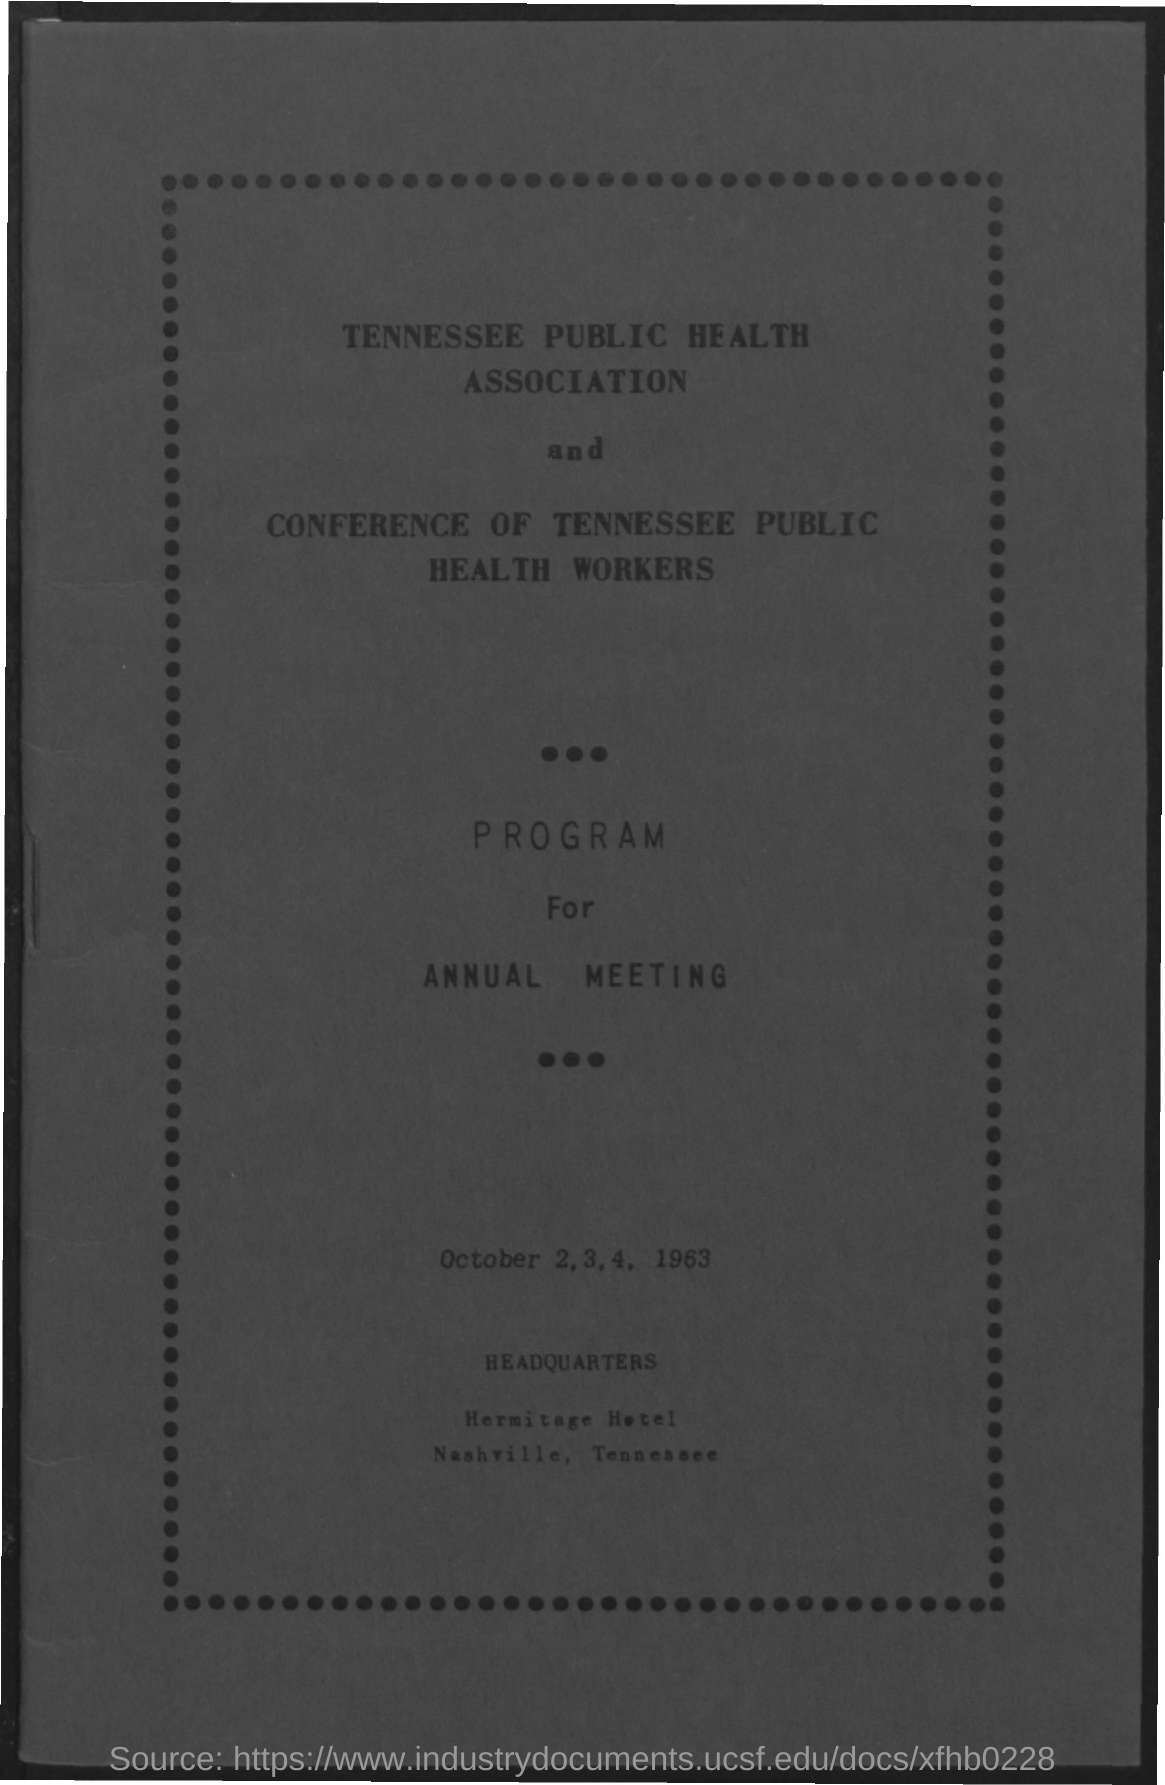What is the name of the association mentioned in the given form ?
Ensure brevity in your answer.  Tennessee Public Health Association. What are the dates mentioned in the given page ?
Provide a succinct answer. October 2,3,4, 1963. What is the name of the hotel mentioned ?
Ensure brevity in your answer.  Hermitage hotel. 